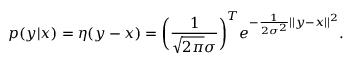<formula> <loc_0><loc_0><loc_500><loc_500>p ( y | x ) = \eta ( y - x ) = \left ( \frac { 1 } { \sqrt { 2 \pi } \sigma } \right ) ^ { T } e ^ { - \frac { 1 } { 2 \sigma ^ { 2 } } | | y - x | | ^ { 2 } } .</formula> 